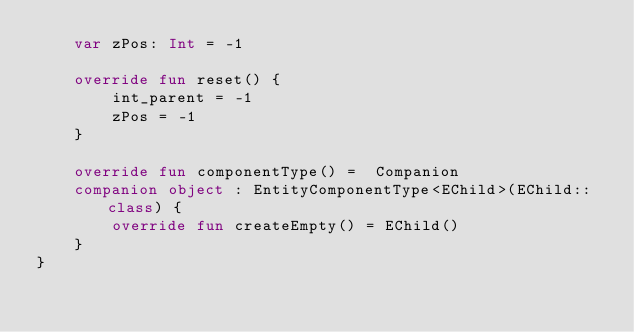Convert code to text. <code><loc_0><loc_0><loc_500><loc_500><_Kotlin_>    var zPos: Int = -1

    override fun reset() {
        int_parent = -1
        zPos = -1
    }

    override fun componentType() =  Companion
    companion object : EntityComponentType<EChild>(EChild::class) {
        override fun createEmpty() = EChild()
    }
}</code> 